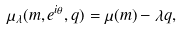<formula> <loc_0><loc_0><loc_500><loc_500>\mu _ { \lambda } ( m , e ^ { i \theta } , q ) = \mu ( m ) - \lambda q ,</formula> 